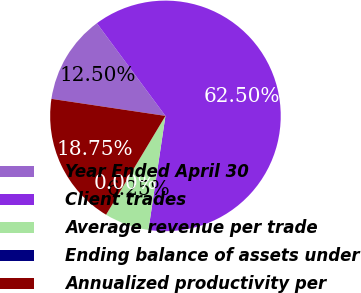<chart> <loc_0><loc_0><loc_500><loc_500><pie_chart><fcel>Year Ended April 30<fcel>Client trades<fcel>Average revenue per trade<fcel>Ending balance of assets under<fcel>Annualized productivity per<nl><fcel>12.5%<fcel>62.5%<fcel>6.25%<fcel>0.0%<fcel>18.75%<nl></chart> 